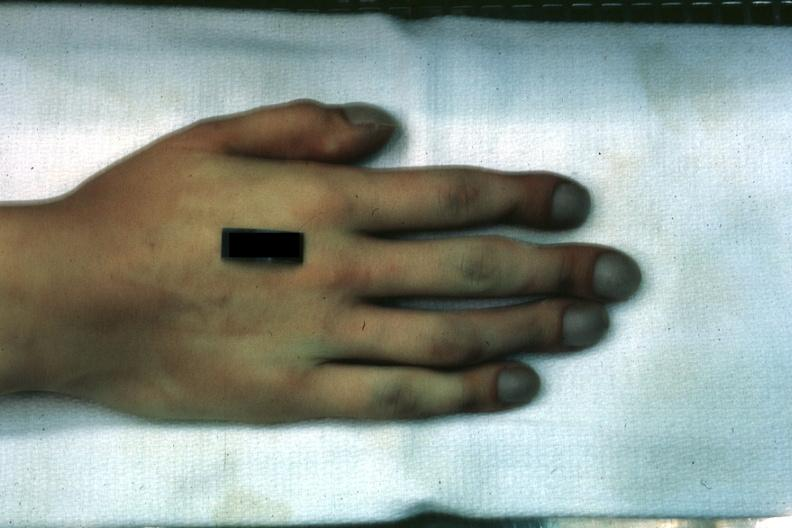how does this image show case of transposition of great vessels?
Answer the question using a single word or phrase. With vsd age 22 yrs 